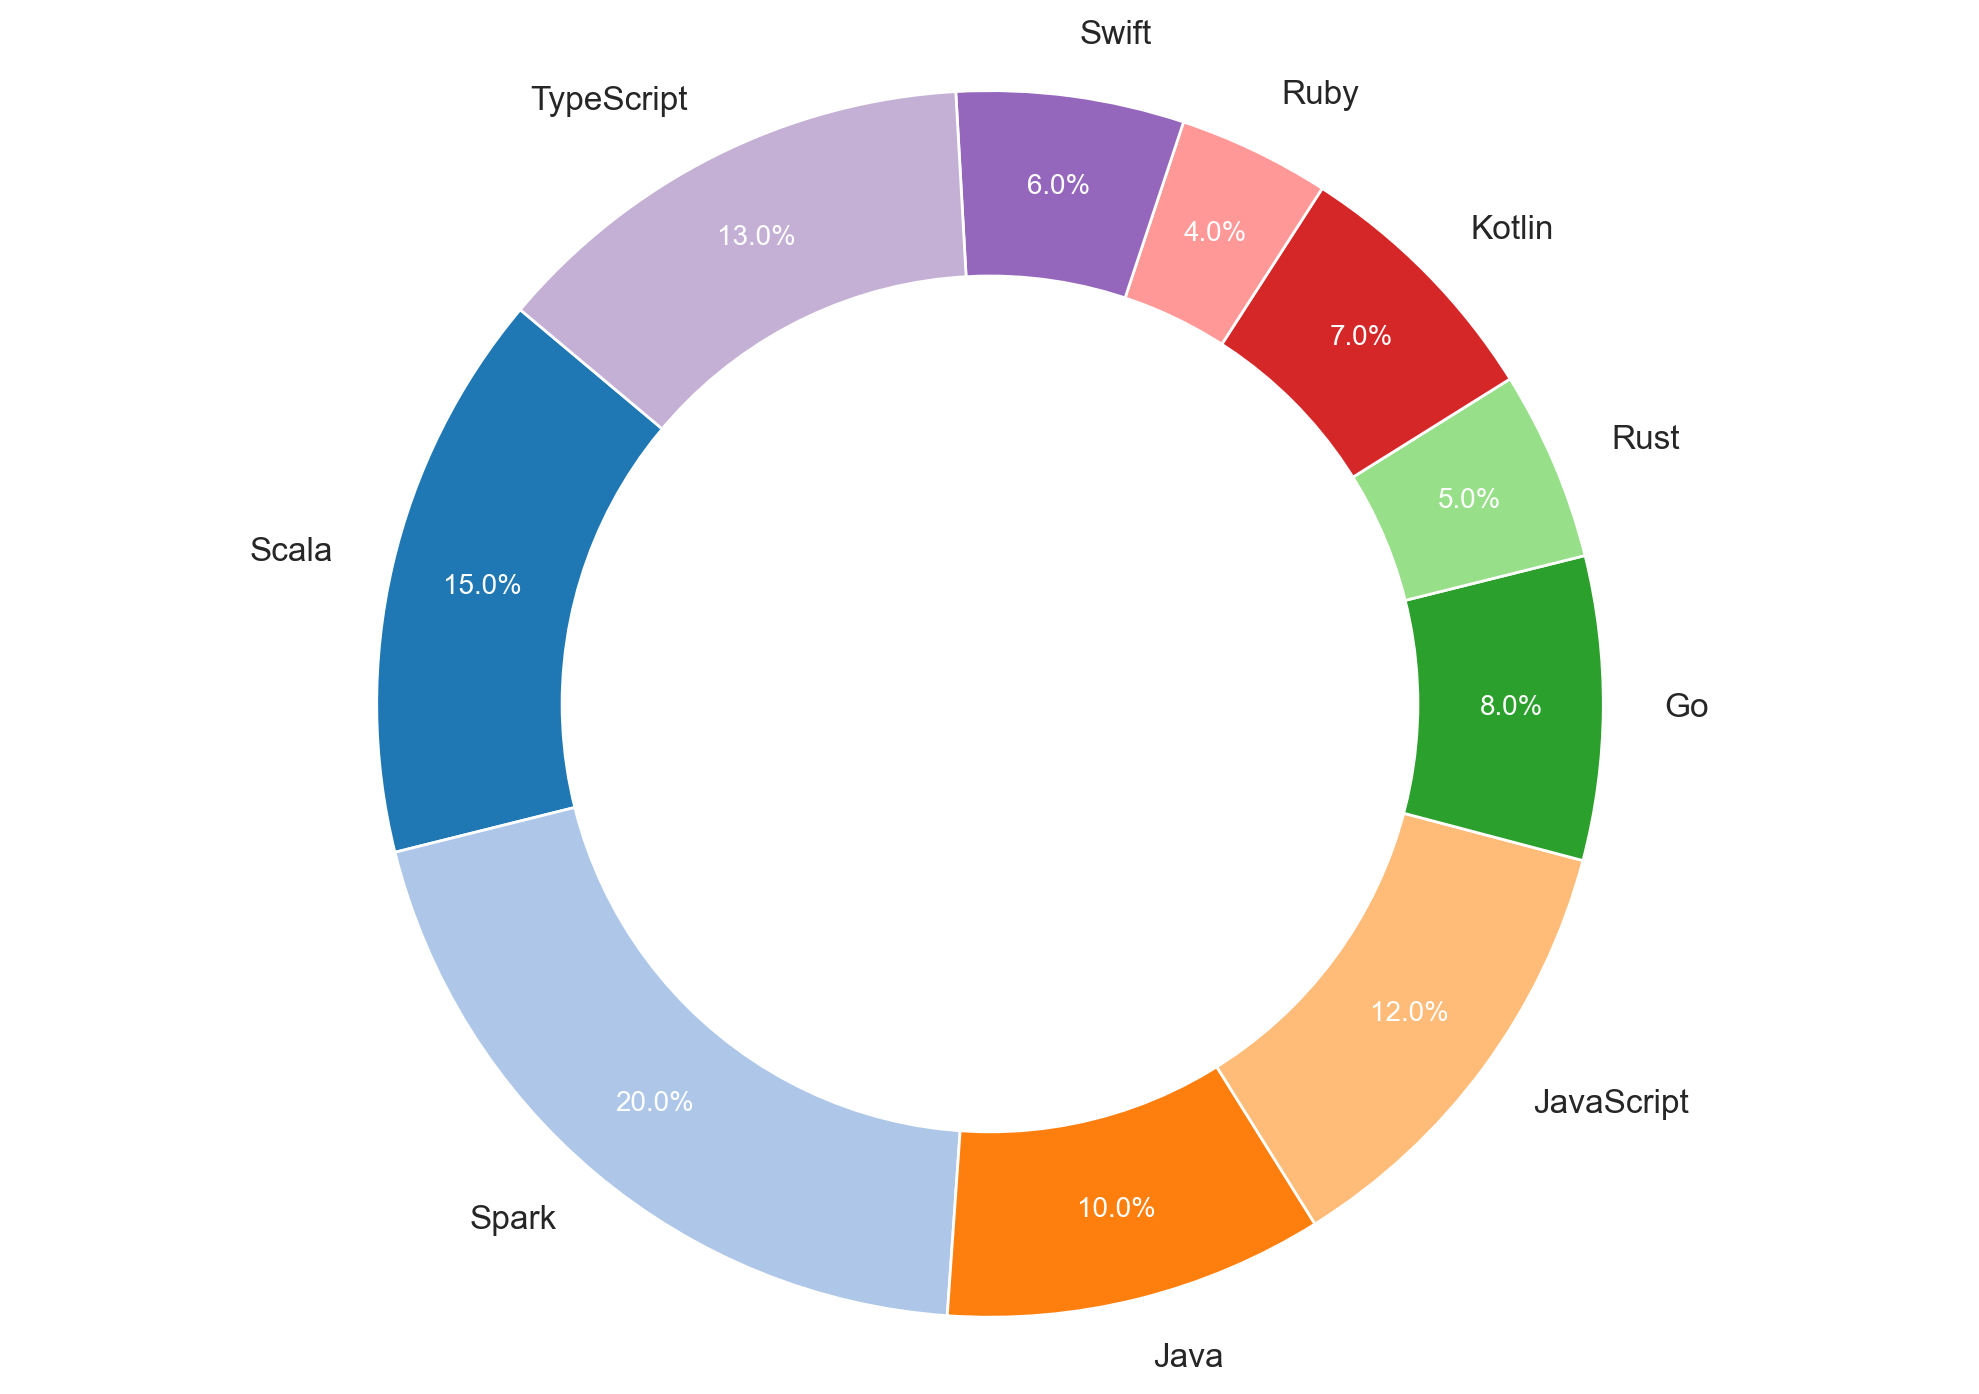what percentage of Python programmers prefer learning Go and Kotlin combined? Add the percentages for Go (8%) and Kotlin (7%) from the chart. 8% + 7% = 15%
Answer: 15% Which programming language is most preferred by Python programmers for learning new skills? Look for the language slice with the largest percentage on the pie chart. Spark has the highest percentage at 20%
Answer: Spark Which programming language has a smaller segment in the pie chart: Rust or Ruby? Compare the percentages for Rust (5%) and Ruby (4%) from the chart. Ruby has a smaller percentage
Answer: Ruby How much more popular is learning Spark compared to learning Java? Subtract the percentage of Java (10%) from the percentage of Spark (20%). 20% - 10% = 10%
Answer: 10% What's the percentage difference between the most and least preferred languages by Python programmers? Determine the highest percentage (Spark, 20%) and the lowest percentage (Ruby, 4%), then subtract the lowest from the highest. 20% - 4% = 16%
Answer: 16% If you combine the preference percentages for Scala, Go, and Swift, what's the total? Add the percentages for Scala (15%), Go (8%), and Swift (6%). 15% + 8% + 6% = 29%
Answer: 29% What's the combined percentage of the top three preferred programming languages? First, identify the top three languages based on percentage: Spark (20%), Scala (15%), and TypeScript (13%). Then add their percentages. 20% + 15% + 13% = 48%
Answer: 48% Which language has a segment closest in size to JavaScript? Compare the percentage of JavaScript (12%) with other percentages in the chart. TypeScript at 13% is the closest
Answer: TypeScript How much larger is the segment for TypeScript compared to Kotlin? Subtract the percentage of Kotlin (7%) from the percentage of TypeScript (13%). 13% - 7% = 6%
Answer: 6% 